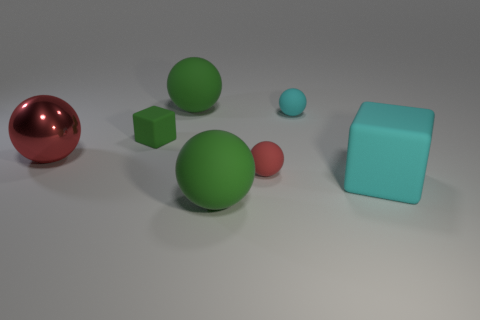Subtract all large balls. How many balls are left? 2 Add 1 tiny green objects. How many objects exist? 8 Subtract all gray blocks. How many red spheres are left? 2 Subtract all balls. How many objects are left? 2 Subtract all cyan spheres. How many spheres are left? 4 Subtract 0 brown cylinders. How many objects are left? 7 Subtract all blue cubes. Subtract all yellow cylinders. How many cubes are left? 2 Subtract all cyan rubber blocks. Subtract all cubes. How many objects are left? 4 Add 1 red matte spheres. How many red matte spheres are left? 2 Add 4 big red spheres. How many big red spheres exist? 5 